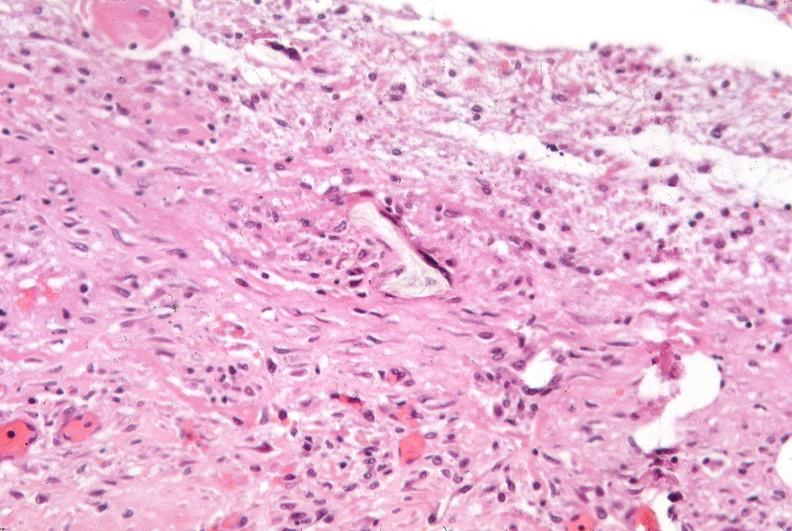s conjoined twins present?
Answer the question using a single word or phrase. No 